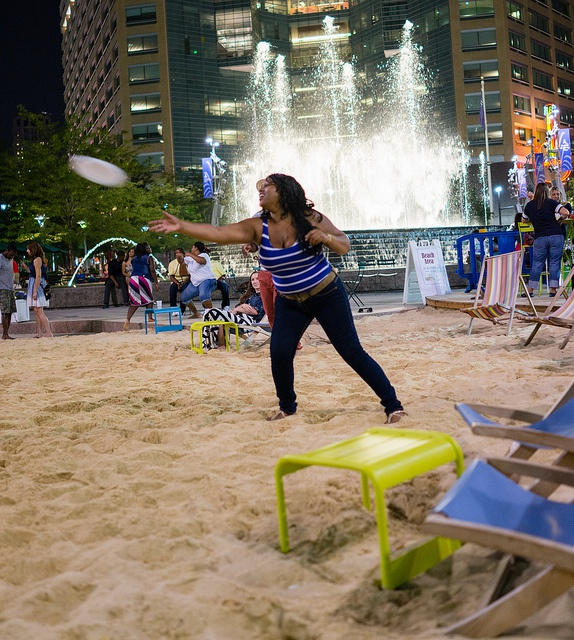Describe the objects in this image and their specific colors. I can see people in black, gray, maroon, and navy tones, chair in black and gray tones, chair in black, gray, maroon, and blue tones, chair in black, darkgray, gray, and pink tones, and people in black, navy, darkblue, and gray tones in this image. 